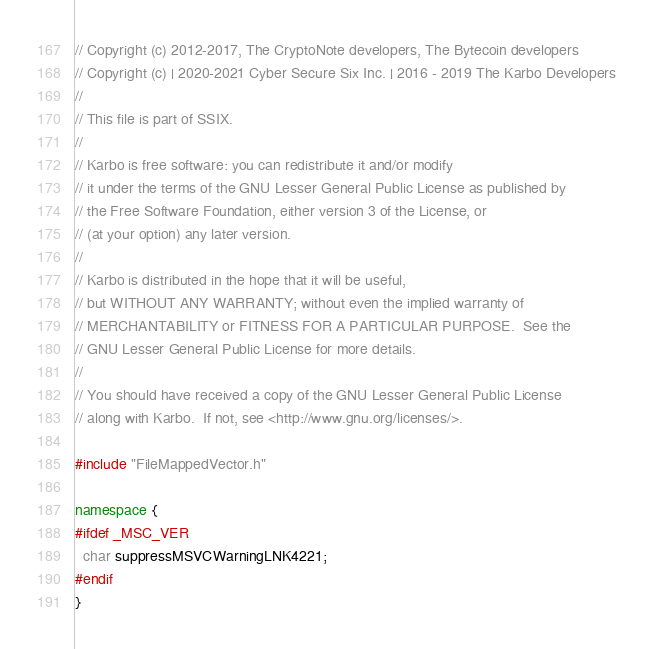<code> <loc_0><loc_0><loc_500><loc_500><_C++_>// Copyright (c) 2012-2017, The CryptoNote developers, The Bytecoin developers
// Copyright (c) | 2020-2021 Cyber Secure Six Inc. | 2016 - 2019 The Karbo Developers
//
// This file is part of SSIX.
//
// Karbo is free software: you can redistribute it and/or modify
// it under the terms of the GNU Lesser General Public License as published by
// the Free Software Foundation, either version 3 of the License, or
// (at your option) any later version.
//
// Karbo is distributed in the hope that it will be useful,
// but WITHOUT ANY WARRANTY; without even the implied warranty of
// MERCHANTABILITY or FITNESS FOR A PARTICULAR PURPOSE.  See the
// GNU Lesser General Public License for more details.
//
// You should have received a copy of the GNU Lesser General Public License
// along with Karbo.  If not, see <http://www.gnu.org/licenses/>.

#include "FileMappedVector.h"

namespace {
#ifdef _MSC_VER
  char suppressMSVCWarningLNK4221;
#endif
}
</code> 